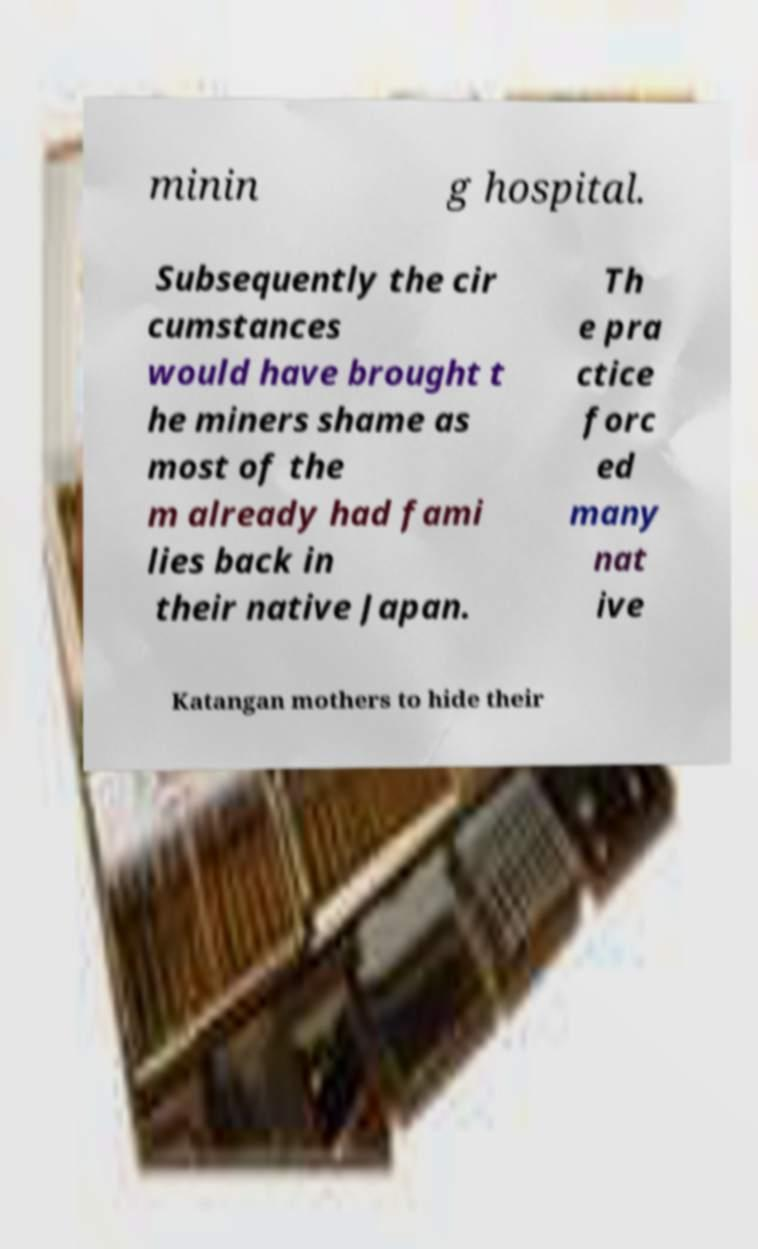I need the written content from this picture converted into text. Can you do that? minin g hospital. Subsequently the cir cumstances would have brought t he miners shame as most of the m already had fami lies back in their native Japan. Th e pra ctice forc ed many nat ive Katangan mothers to hide their 